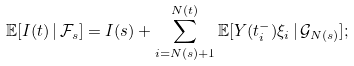Convert formula to latex. <formula><loc_0><loc_0><loc_500><loc_500>\mathbb { E } [ I ( t ) \, | \, \mathcal { F } _ { s } ] = I ( s ) + \sum _ { i = N ( s ) + 1 } ^ { N ( t ) } \mathbb { E } [ Y ( t _ { i } ^ { - } ) \xi _ { i } \, | \, \mathcal { G } _ { N ( s ) } ] ;</formula> 